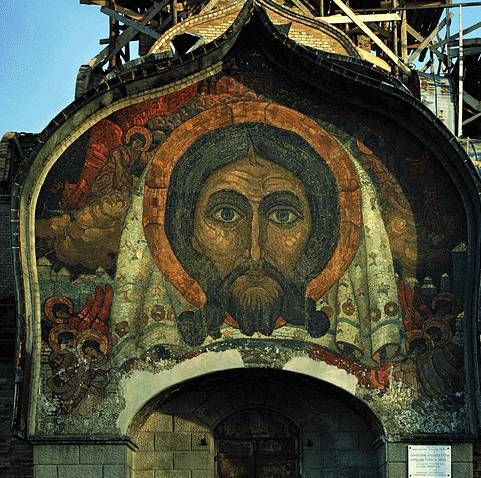Can you explain the significance of the scaffolding visible in the image? The scaffolding in front of the mosaic suggests that the artwork is currently undergoing restoration or preservation efforts. This is crucial for maintaining the integrity and beauty of historic artworks, especially in dealing with mosaics that may face issues like peeling or fading over time. The commitment to preserving such a piece underscores the value placed on heritage and religious art. It also provides a glimpse into the continual care and attention that heritage sites receive to bridge historical artistry with modern appreciation. 